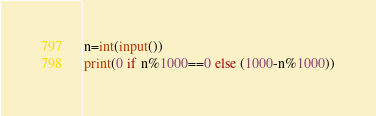Convert code to text. <code><loc_0><loc_0><loc_500><loc_500><_Python_>n=int(input())
print(0 if n%1000==0 else (1000-n%1000))</code> 